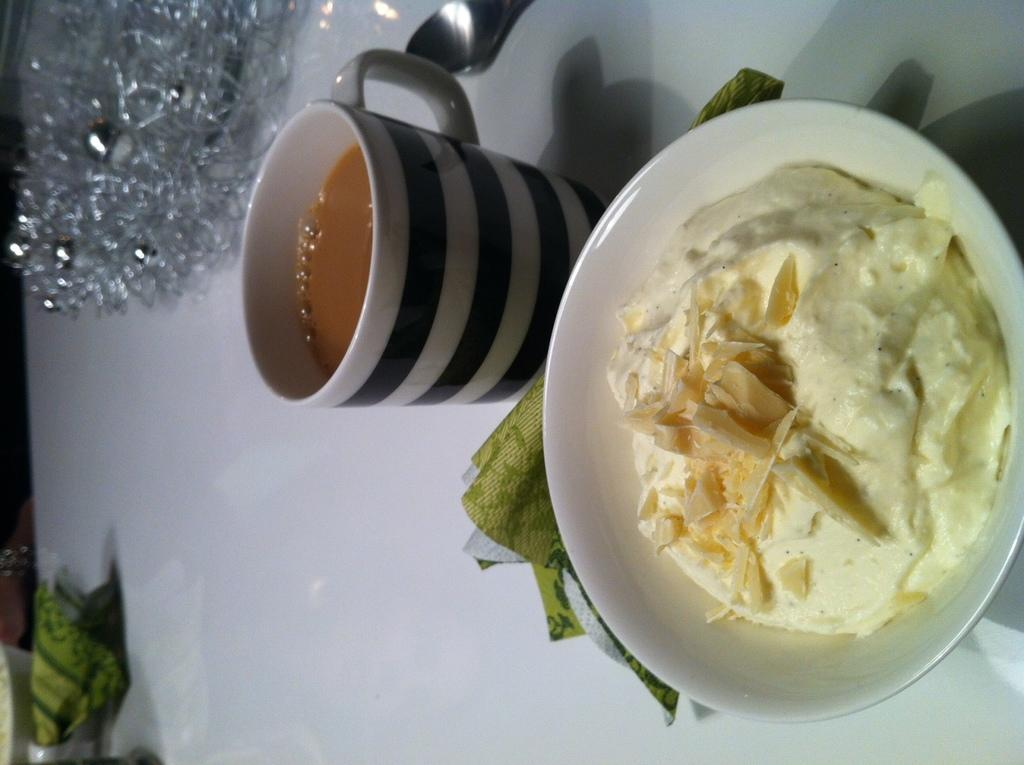What piece of furniture is present in the image? There is a table in the image. What is placed on the table? There is a tea cup and a bowl with food on the table. Are there any other objects on the table? Yes, there are other objects on the table. What holiday is being celebrated in the image? There is no indication of a holiday being celebrated in the image. What reward is being given to the person in the image? There is no person or reward present in the image. 